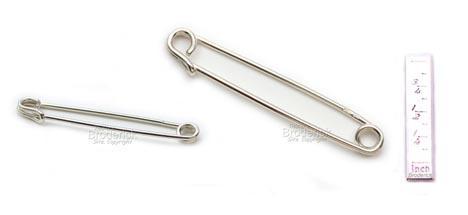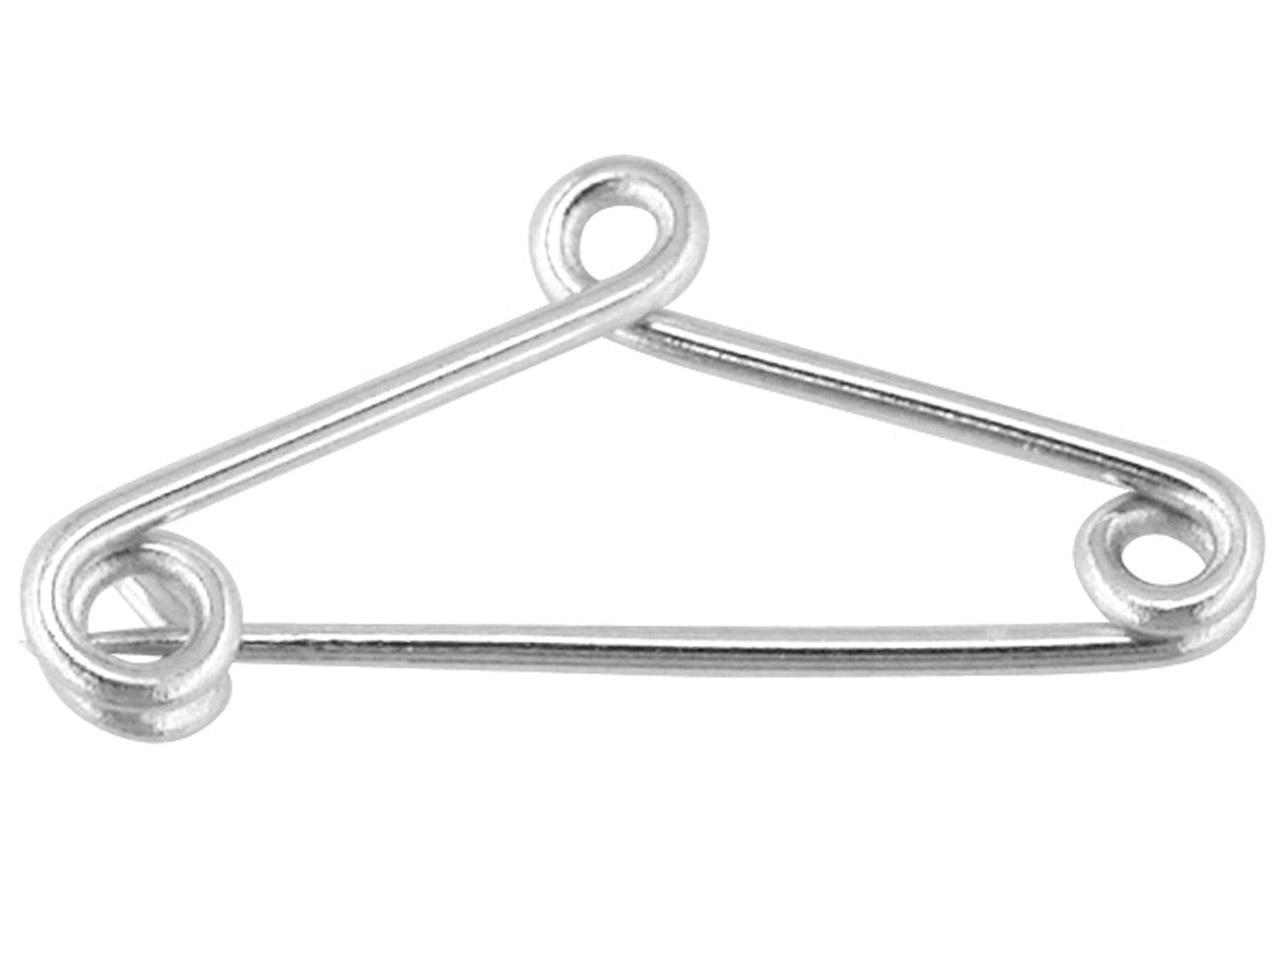The first image is the image on the left, the second image is the image on the right. Given the left and right images, does the statement "An image shows exactly one safety pin, which is strung with a horse-head shape charm." hold true? Answer yes or no. No. The first image is the image on the left, the second image is the image on the right. Examine the images to the left and right. Is the description "One image shows exactly two pins and both of those pins are closed." accurate? Answer yes or no. Yes. 